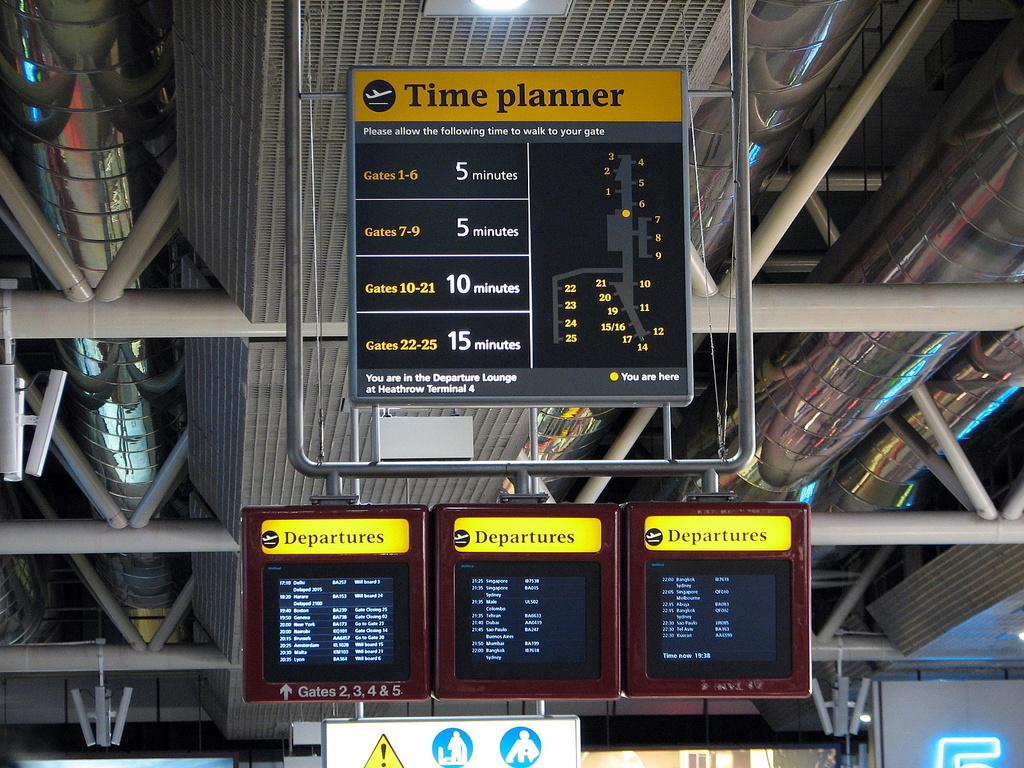What objects can be seen in the image? There are boards, pipes, and rods in the image. Where is the light located in the image? The light is at the top of the image. What type of brain can be seen in the image? There is no brain present in the image. Can you tell me how many donkeys are visible in the image? There are no donkeys present in the image. 